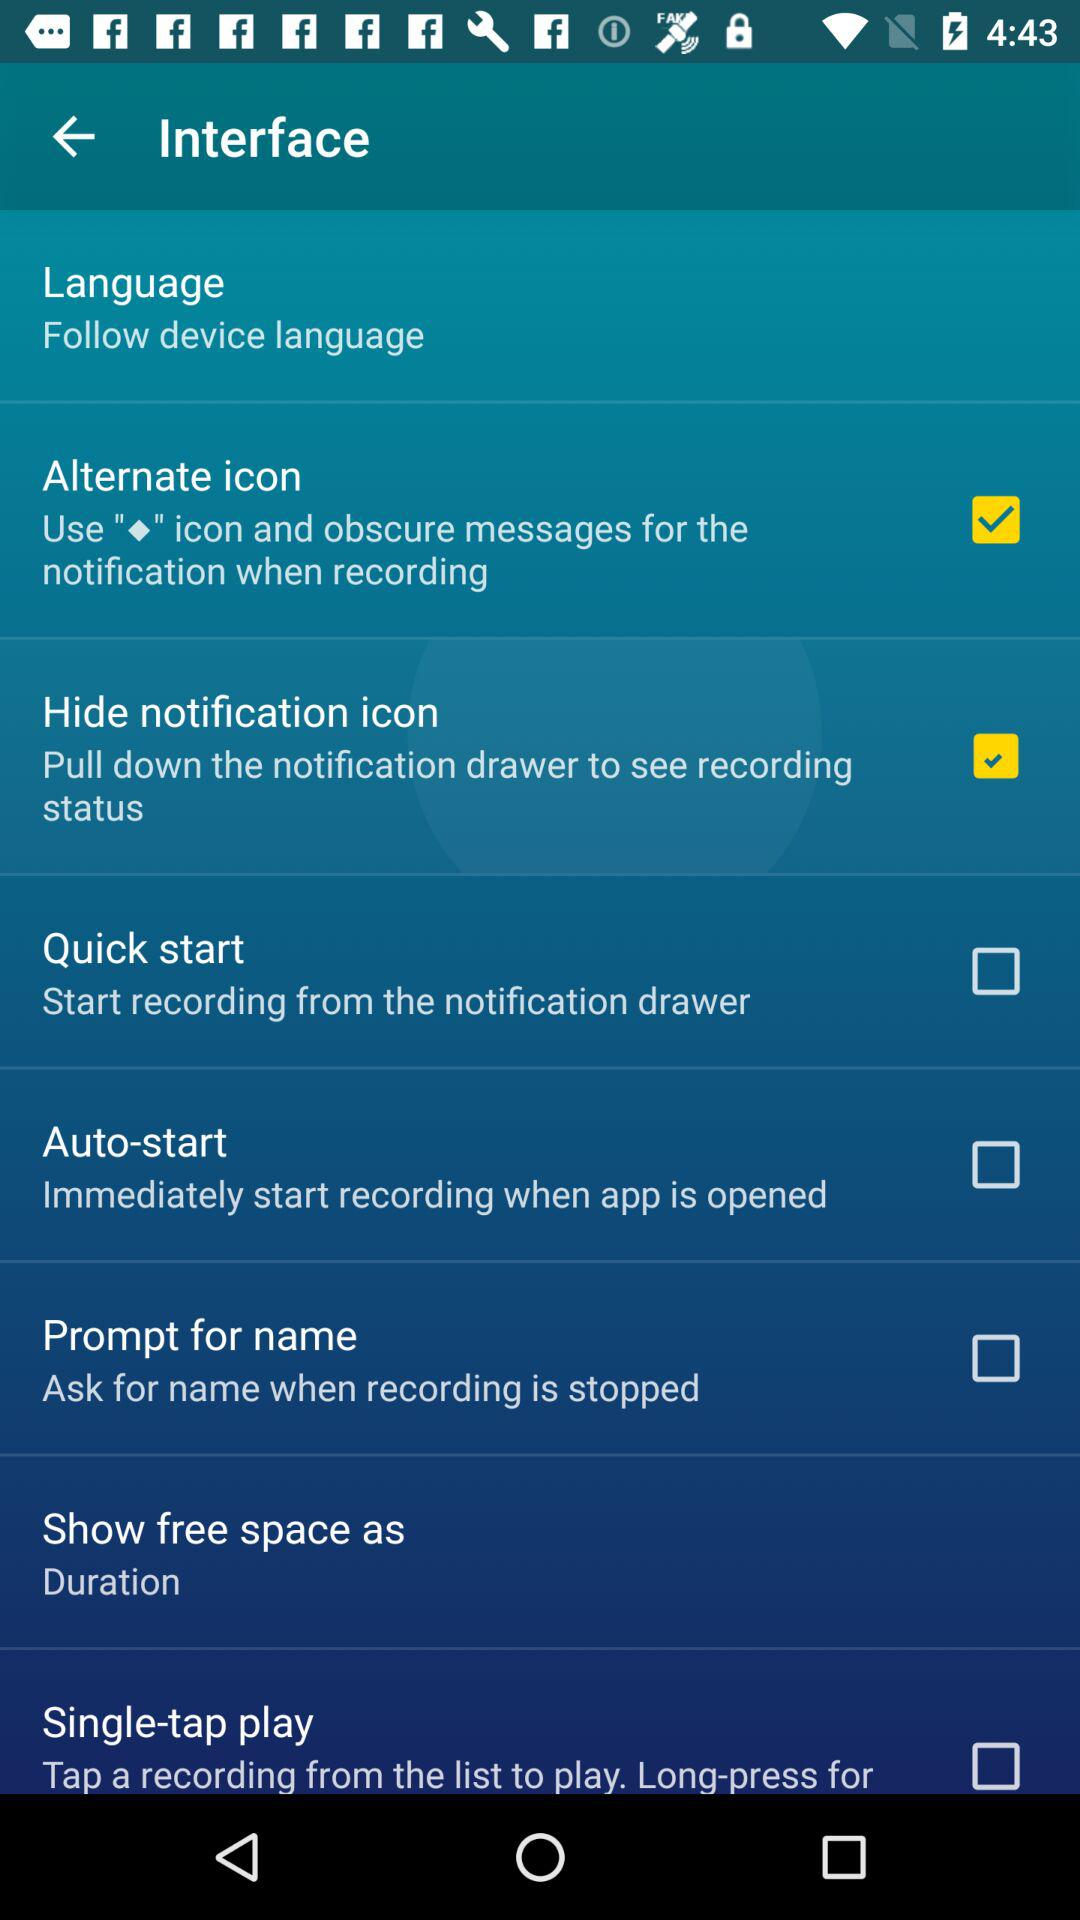Which option is marked checked? The options that are marked as checked are "Alternate icon" and "Hide notification icon". 